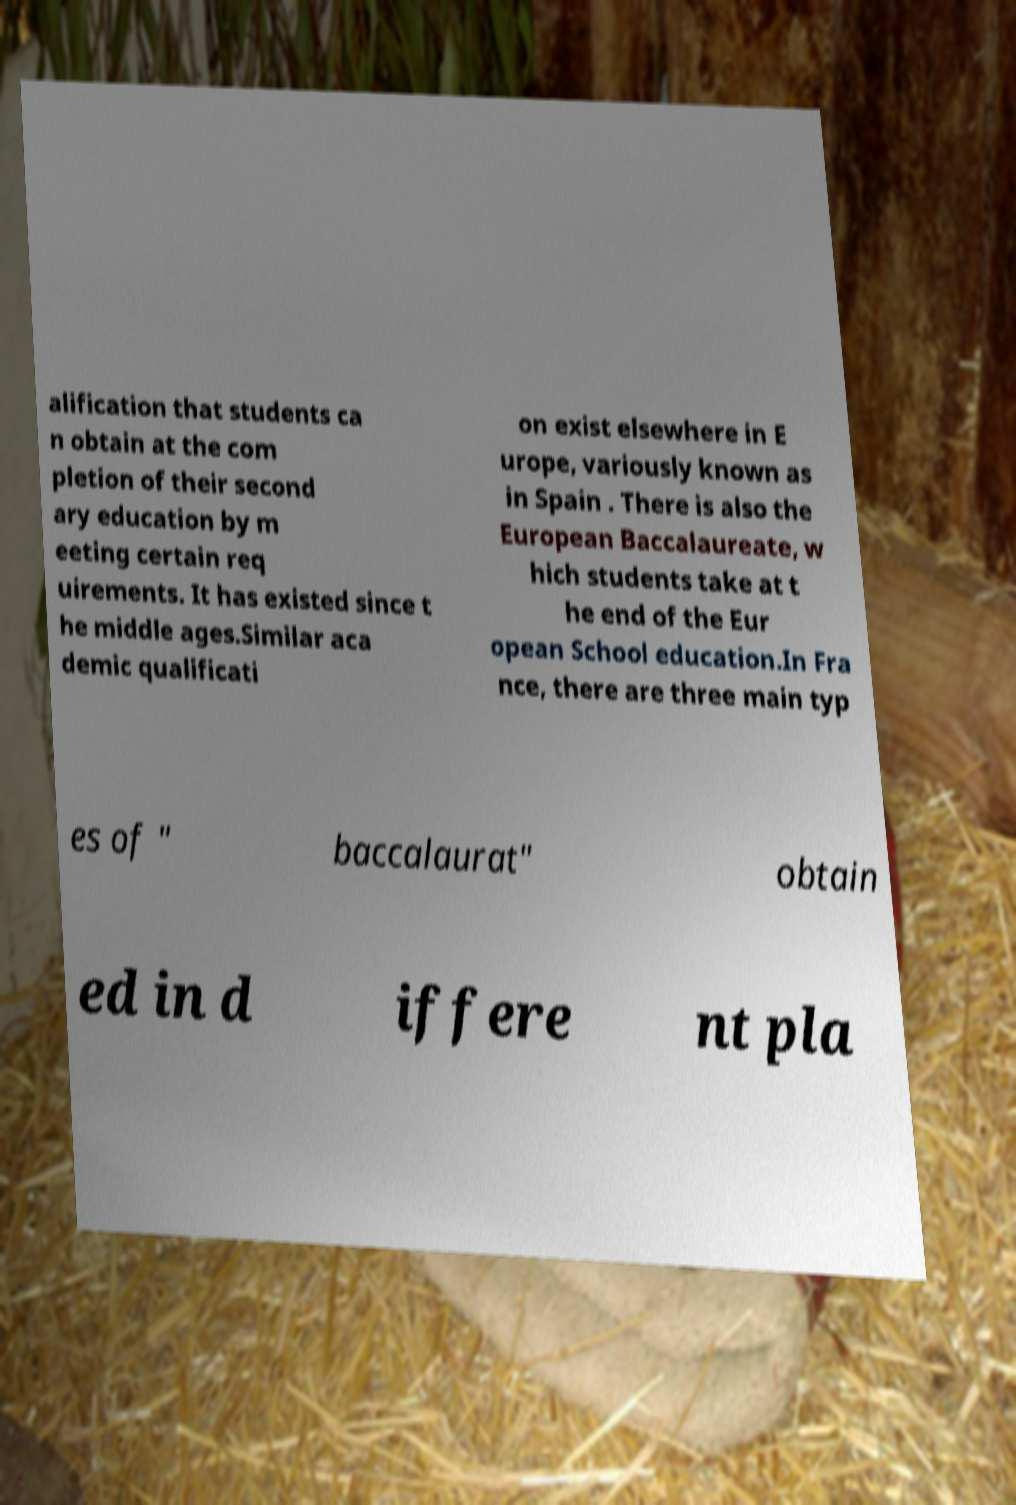Could you assist in decoding the text presented in this image and type it out clearly? alification that students ca n obtain at the com pletion of their second ary education by m eeting certain req uirements. It has existed since t he middle ages.Similar aca demic qualificati on exist elsewhere in E urope, variously known as in Spain . There is also the European Baccalaureate, w hich students take at t he end of the Eur opean School education.In Fra nce, there are three main typ es of " baccalaurat" obtain ed in d iffere nt pla 